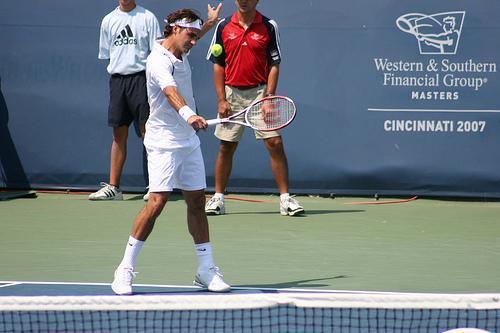How many racquets shown?
Give a very brief answer. 1. 